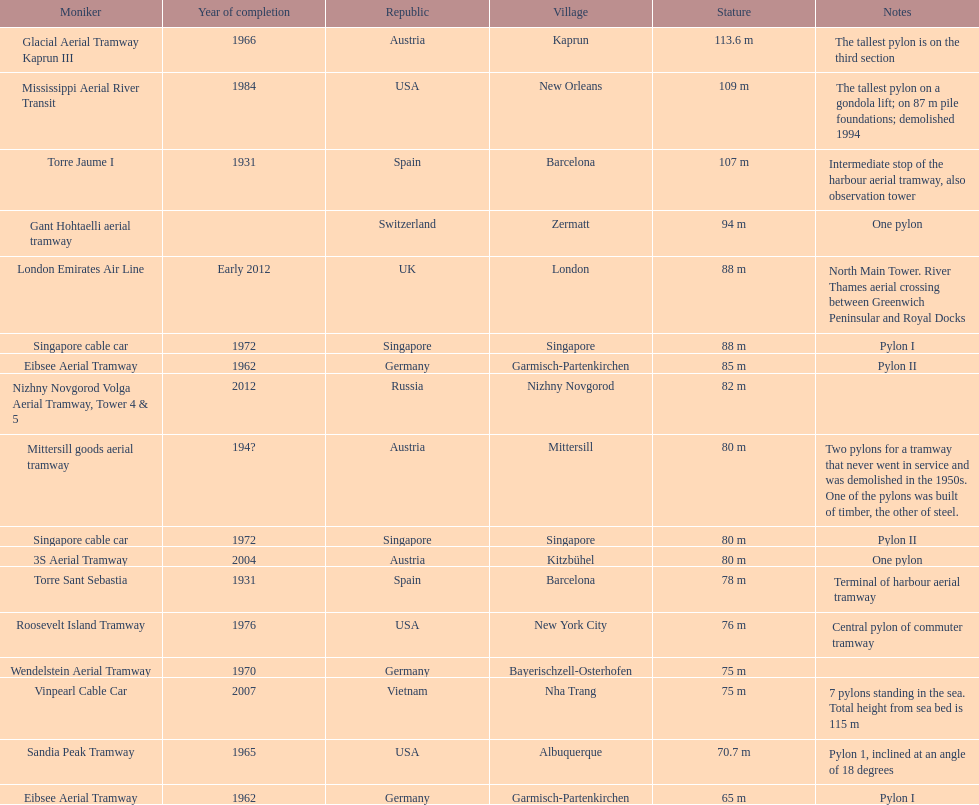What year was the last pylon in germany built? 1970. 